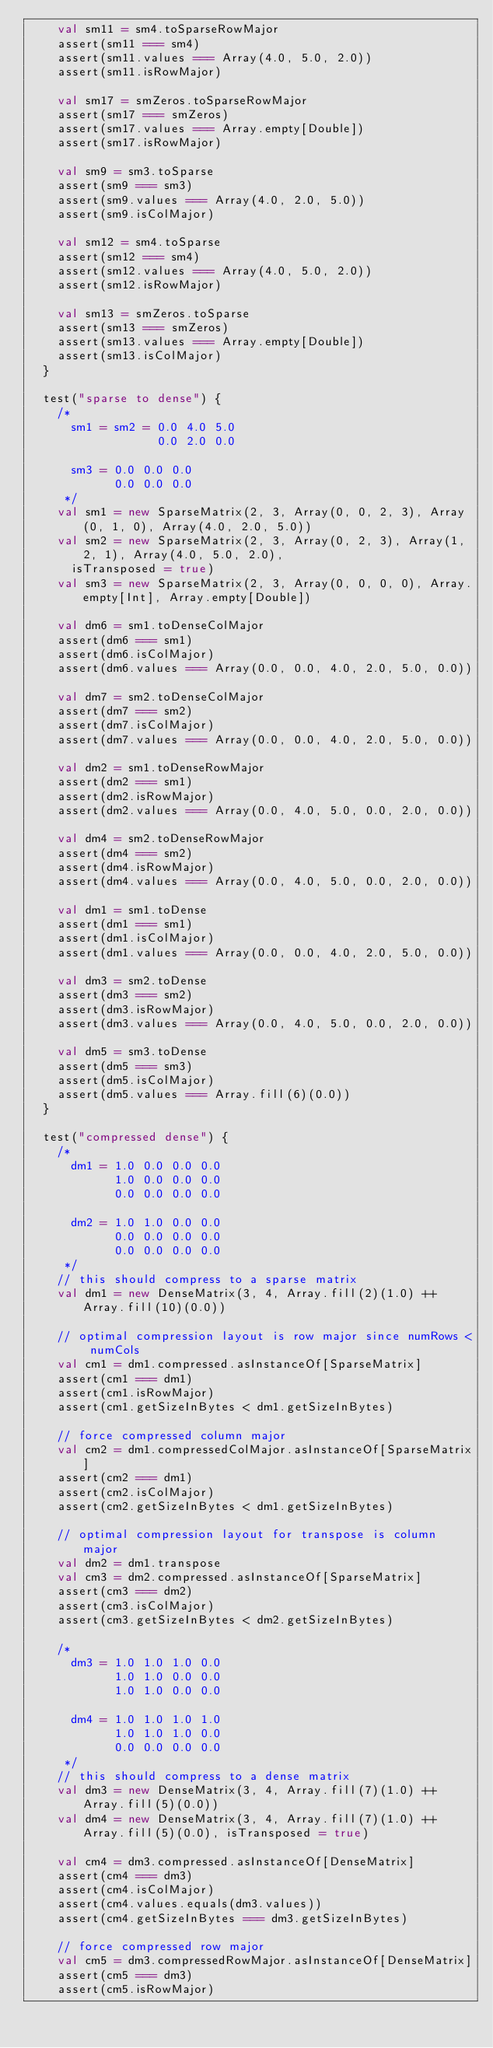Convert code to text. <code><loc_0><loc_0><loc_500><loc_500><_Scala_>    val sm11 = sm4.toSparseRowMajor
    assert(sm11 === sm4)
    assert(sm11.values === Array(4.0, 5.0, 2.0))
    assert(sm11.isRowMajor)

    val sm17 = smZeros.toSparseRowMajor
    assert(sm17 === smZeros)
    assert(sm17.values === Array.empty[Double])
    assert(sm17.isRowMajor)

    val sm9 = sm3.toSparse
    assert(sm9 === sm3)
    assert(sm9.values === Array(4.0, 2.0, 5.0))
    assert(sm9.isColMajor)

    val sm12 = sm4.toSparse
    assert(sm12 === sm4)
    assert(sm12.values === Array(4.0, 5.0, 2.0))
    assert(sm12.isRowMajor)

    val sm13 = smZeros.toSparse
    assert(sm13 === smZeros)
    assert(sm13.values === Array.empty[Double])
    assert(sm13.isColMajor)
  }

  test("sparse to dense") {
    /*
      sm1 = sm2 = 0.0 4.0 5.0
                  0.0 2.0 0.0

      sm3 = 0.0 0.0 0.0
            0.0 0.0 0.0
     */
    val sm1 = new SparseMatrix(2, 3, Array(0, 0, 2, 3), Array(0, 1, 0), Array(4.0, 2.0, 5.0))
    val sm2 = new SparseMatrix(2, 3, Array(0, 2, 3), Array(1, 2, 1), Array(4.0, 5.0, 2.0),
      isTransposed = true)
    val sm3 = new SparseMatrix(2, 3, Array(0, 0, 0, 0), Array.empty[Int], Array.empty[Double])

    val dm6 = sm1.toDenseColMajor
    assert(dm6 === sm1)
    assert(dm6.isColMajor)
    assert(dm6.values === Array(0.0, 0.0, 4.0, 2.0, 5.0, 0.0))

    val dm7 = sm2.toDenseColMajor
    assert(dm7 === sm2)
    assert(dm7.isColMajor)
    assert(dm7.values === Array(0.0, 0.0, 4.0, 2.0, 5.0, 0.0))

    val dm2 = sm1.toDenseRowMajor
    assert(dm2 === sm1)
    assert(dm2.isRowMajor)
    assert(dm2.values === Array(0.0, 4.0, 5.0, 0.0, 2.0, 0.0))

    val dm4 = sm2.toDenseRowMajor
    assert(dm4 === sm2)
    assert(dm4.isRowMajor)
    assert(dm4.values === Array(0.0, 4.0, 5.0, 0.0, 2.0, 0.0))

    val dm1 = sm1.toDense
    assert(dm1 === sm1)
    assert(dm1.isColMajor)
    assert(dm1.values === Array(0.0, 0.0, 4.0, 2.0, 5.0, 0.0))

    val dm3 = sm2.toDense
    assert(dm3 === sm2)
    assert(dm3.isRowMajor)
    assert(dm3.values === Array(0.0, 4.0, 5.0, 0.0, 2.0, 0.0))

    val dm5 = sm3.toDense
    assert(dm5 === sm3)
    assert(dm5.isColMajor)
    assert(dm5.values === Array.fill(6)(0.0))
  }

  test("compressed dense") {
    /*
      dm1 = 1.0 0.0 0.0 0.0
            1.0 0.0 0.0 0.0
            0.0 0.0 0.0 0.0

      dm2 = 1.0 1.0 0.0 0.0
            0.0 0.0 0.0 0.0
            0.0 0.0 0.0 0.0
     */
    // this should compress to a sparse matrix
    val dm1 = new DenseMatrix(3, 4, Array.fill(2)(1.0) ++ Array.fill(10)(0.0))

    // optimal compression layout is row major since numRows < numCols
    val cm1 = dm1.compressed.asInstanceOf[SparseMatrix]
    assert(cm1 === dm1)
    assert(cm1.isRowMajor)
    assert(cm1.getSizeInBytes < dm1.getSizeInBytes)

    // force compressed column major
    val cm2 = dm1.compressedColMajor.asInstanceOf[SparseMatrix]
    assert(cm2 === dm1)
    assert(cm2.isColMajor)
    assert(cm2.getSizeInBytes < dm1.getSizeInBytes)

    // optimal compression layout for transpose is column major
    val dm2 = dm1.transpose
    val cm3 = dm2.compressed.asInstanceOf[SparseMatrix]
    assert(cm3 === dm2)
    assert(cm3.isColMajor)
    assert(cm3.getSizeInBytes < dm2.getSizeInBytes)

    /*
      dm3 = 1.0 1.0 1.0 0.0
            1.0 1.0 0.0 0.0
            1.0 1.0 0.0 0.0

      dm4 = 1.0 1.0 1.0 1.0
            1.0 1.0 1.0 0.0
            0.0 0.0 0.0 0.0
     */
    // this should compress to a dense matrix
    val dm3 = new DenseMatrix(3, 4, Array.fill(7)(1.0) ++ Array.fill(5)(0.0))
    val dm4 = new DenseMatrix(3, 4, Array.fill(7)(1.0) ++ Array.fill(5)(0.0), isTransposed = true)

    val cm4 = dm3.compressed.asInstanceOf[DenseMatrix]
    assert(cm4 === dm3)
    assert(cm4.isColMajor)
    assert(cm4.values.equals(dm3.values))
    assert(cm4.getSizeInBytes === dm3.getSizeInBytes)

    // force compressed row major
    val cm5 = dm3.compressedRowMajor.asInstanceOf[DenseMatrix]
    assert(cm5 === dm3)
    assert(cm5.isRowMajor)</code> 